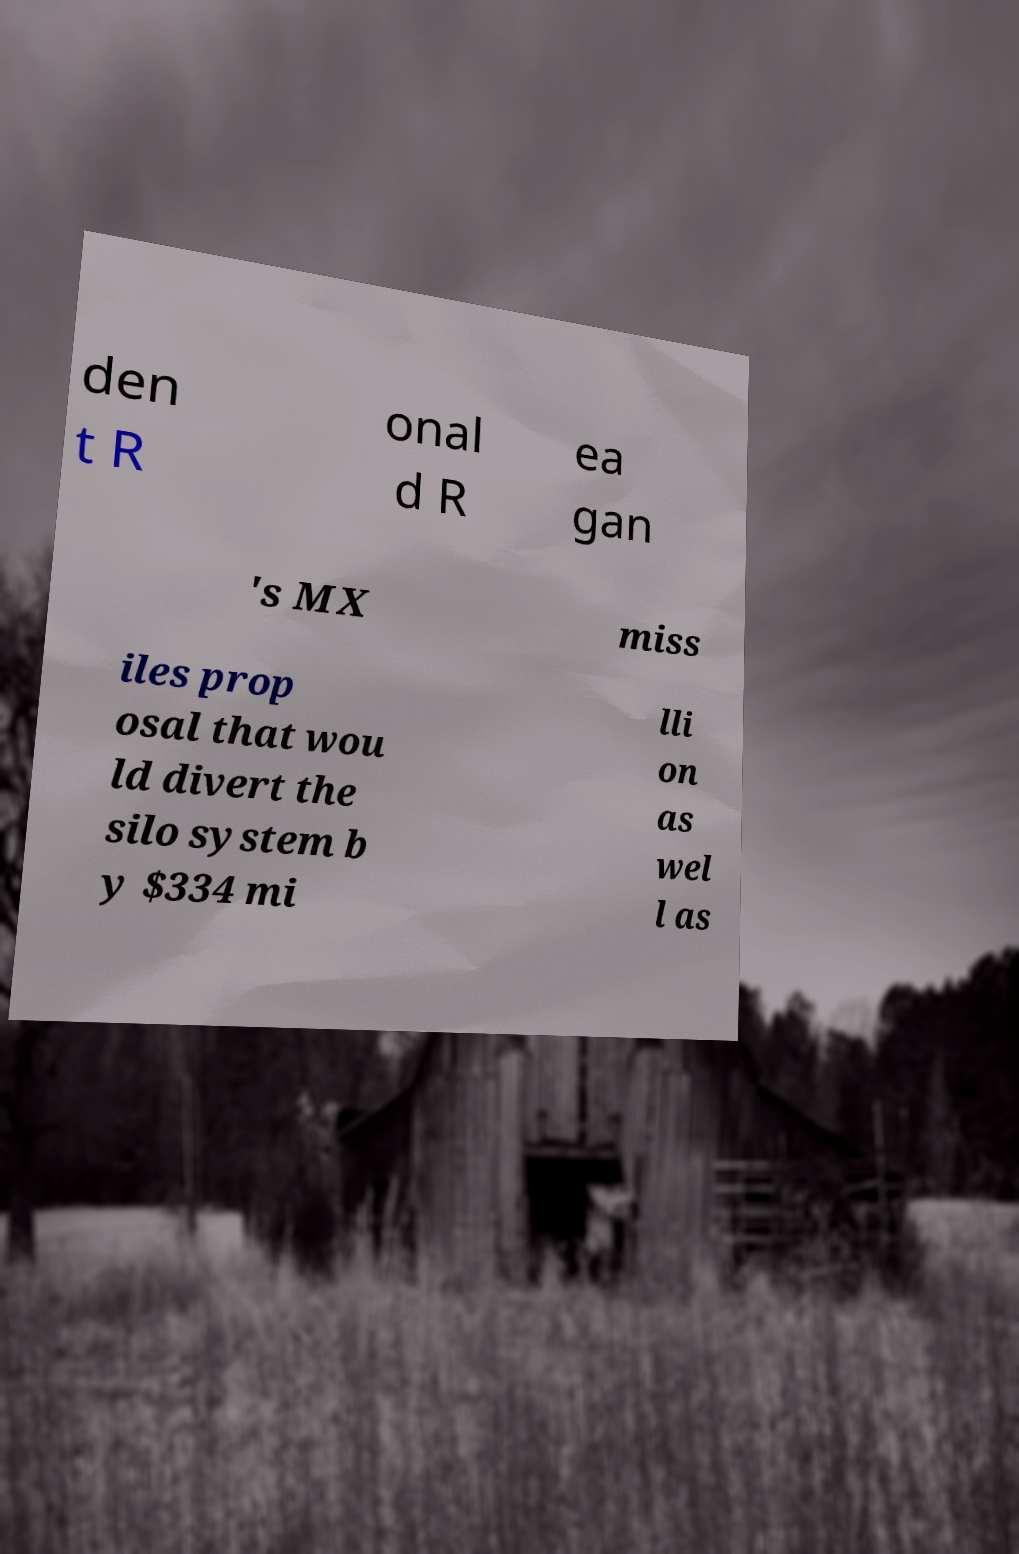Please identify and transcribe the text found in this image. den t R onal d R ea gan 's MX miss iles prop osal that wou ld divert the silo system b y $334 mi lli on as wel l as 